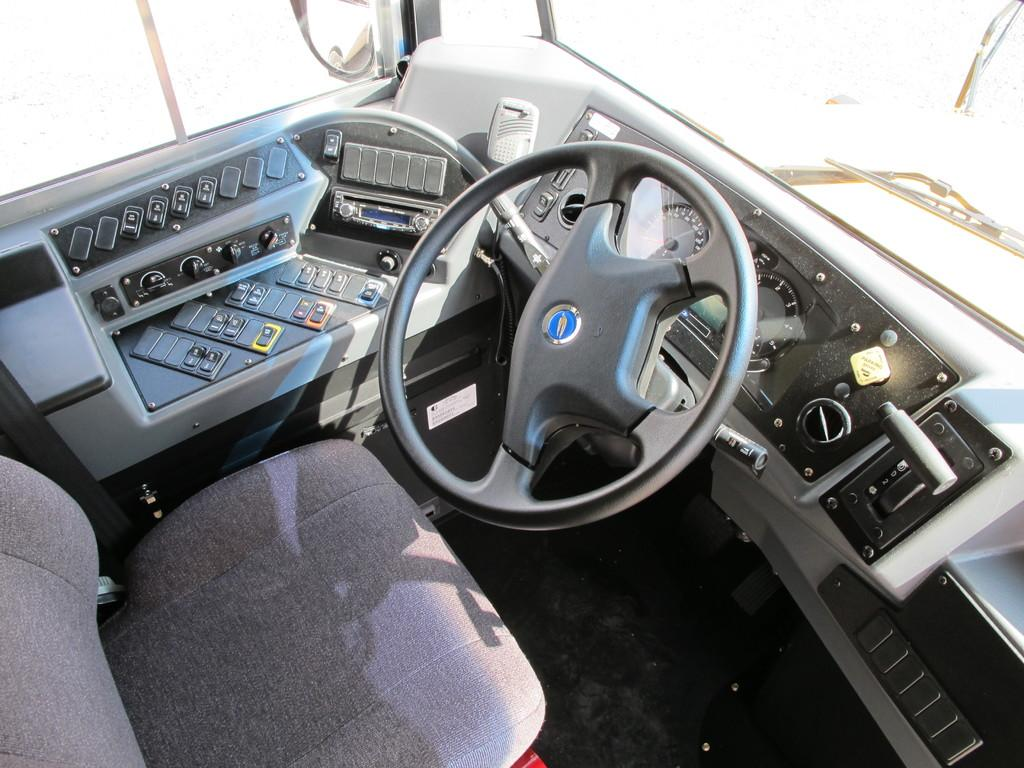What type of space is shown in the image? The image shows the inside part of a vehicle. What can be seen on a board in the image? There are buttons on a board in the image. What is present for the driver to sit on? There is a chair in the image. What is used to control the direction of the vehicle? A steering wheel is visible in the image. What is used to see behind the vehicle? There is a mirror in the image. What other objects can be seen in the image? There are other objects present in the image. How many men are seen falling from the vehicle in the image? There are no men or falling actions depicted in the image. 